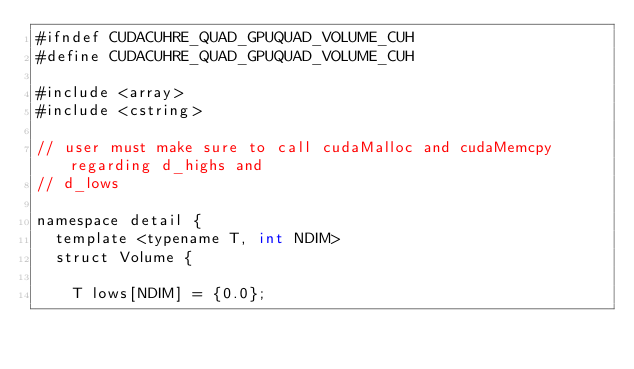<code> <loc_0><loc_0><loc_500><loc_500><_Cuda_>#ifndef CUDACUHRE_QUAD_GPUQUAD_VOLUME_CUH
#define CUDACUHRE_QUAD_GPUQUAD_VOLUME_CUH

#include <array>
#include <cstring>

// user must make sure to call cudaMalloc and cudaMemcpy regarding d_highs and
// d_lows

namespace detail {
  template <typename T, int NDIM>
  struct Volume {

    T lows[NDIM] = {0.0};</code> 